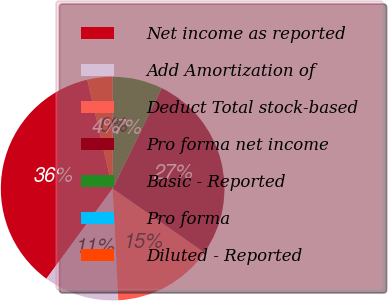<chart> <loc_0><loc_0><loc_500><loc_500><pie_chart><fcel>Net income as reported<fcel>Add Amortization of<fcel>Deduct Total stock-based<fcel>Pro forma net income<fcel>Basic - Reported<fcel>Pro forma<fcel>Diluted - Reported<nl><fcel>36.27%<fcel>10.88%<fcel>14.51%<fcel>27.45%<fcel>7.25%<fcel>0.0%<fcel>3.63%<nl></chart> 